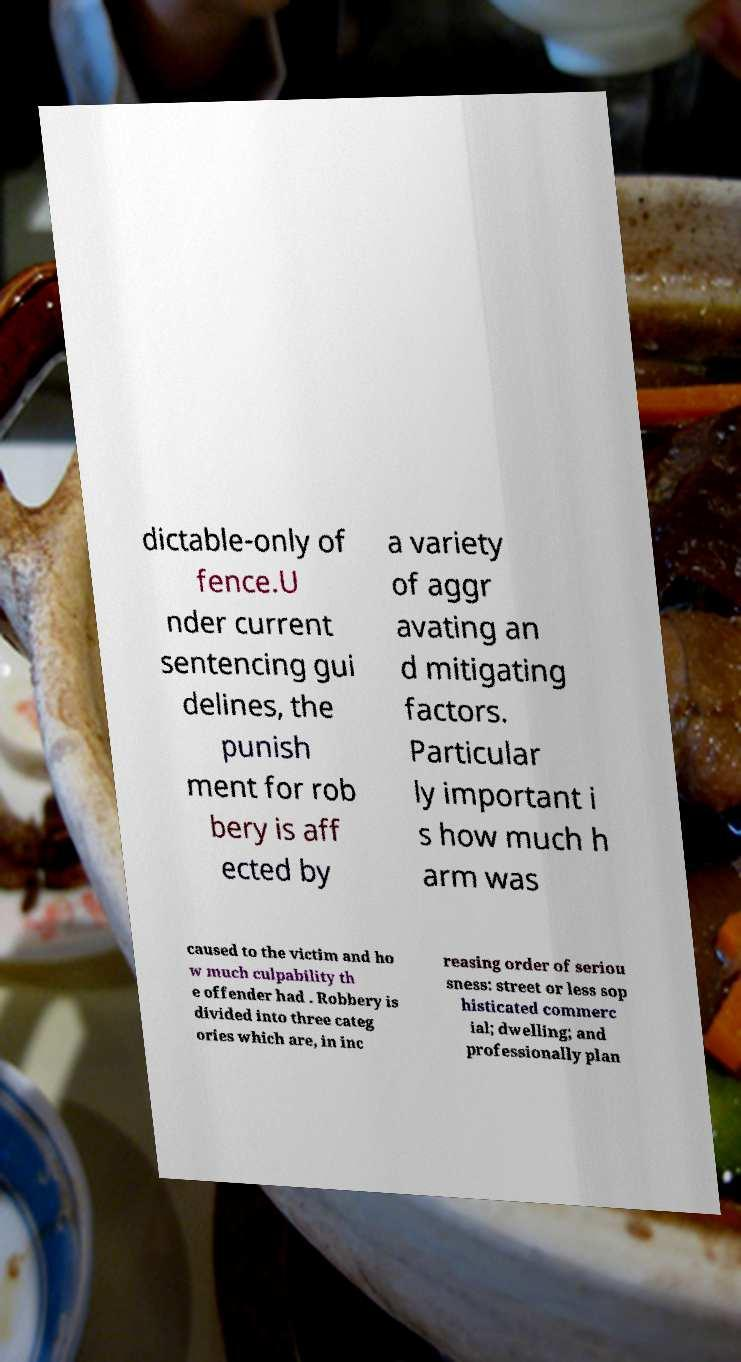There's text embedded in this image that I need extracted. Can you transcribe it verbatim? dictable-only of fence.U nder current sentencing gui delines, the punish ment for rob bery is aff ected by a variety of aggr avating an d mitigating factors. Particular ly important i s how much h arm was caused to the victim and ho w much culpability th e offender had . Robbery is divided into three categ ories which are, in inc reasing order of seriou sness: street or less sop histicated commerc ial; dwelling; and professionally plan 